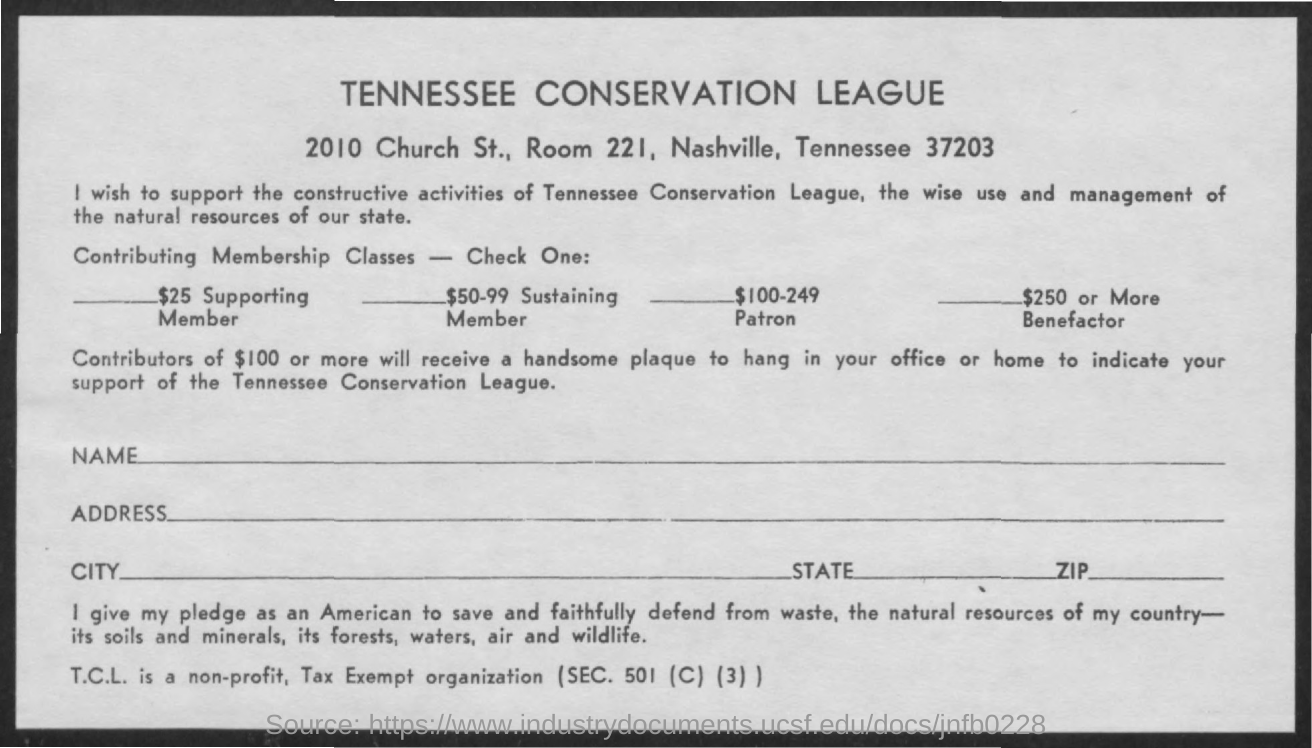What is the room no mentioned ?
Offer a terse response. Room 221. What is the title mentioned in the bold letters
Provide a succinct answer. TENNESSEE  CONSERVATION LEAGUE. What is the full form of tcl ?
Make the answer very short. Tennessee Conservation League. What is the sec no mentioned ?
Your response must be concise. Sec. 501 (C) (3). 